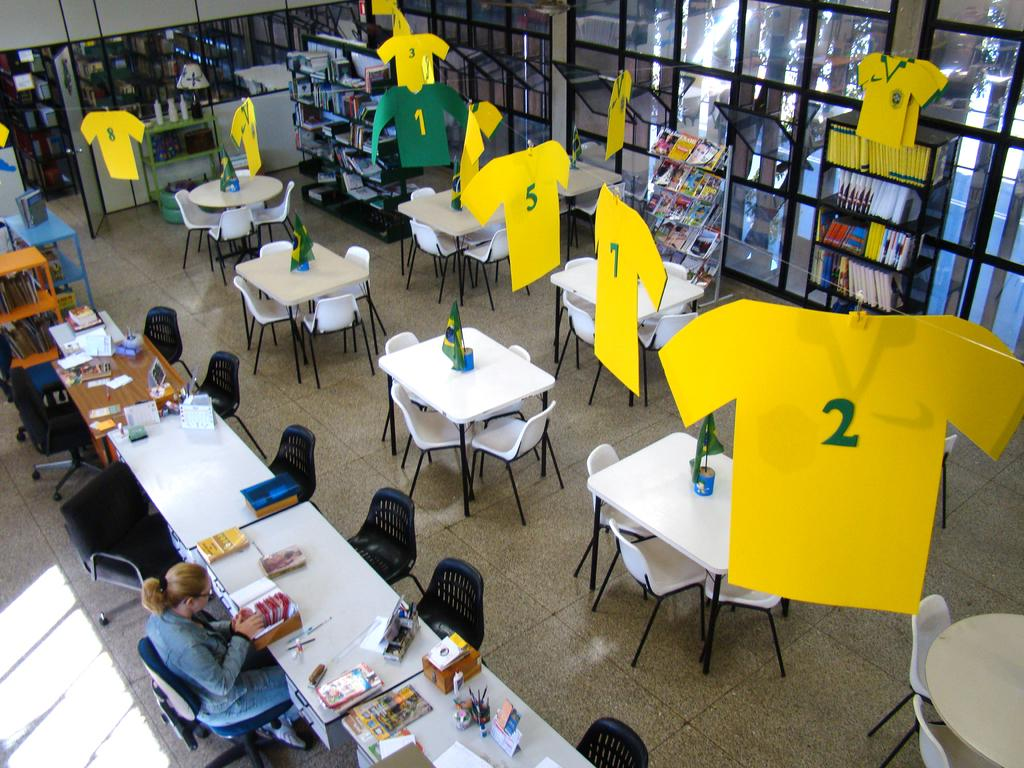Who is present in the image? There is a woman in the image. Where is the woman located? The woman is sitting in a library. What is the woman doing in the library? The woman is searching for books. Can you see a robin flying over the woman in the image? There is no robin present in the image. What is the woman saying to the librarian as she says good-bye? The image does not show the woman saying good-bye or interacting with a librarian, so we cannot determine what she might be saying. 